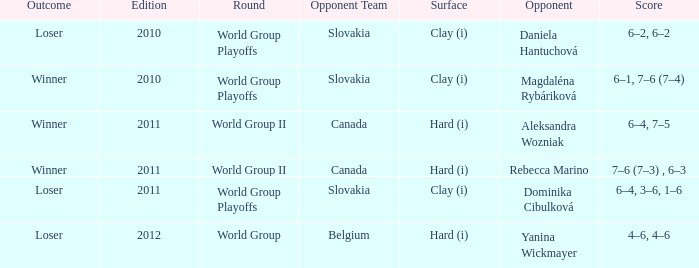When playing against aleksandra wozniak, what was the count of outcomes? 1.0. 